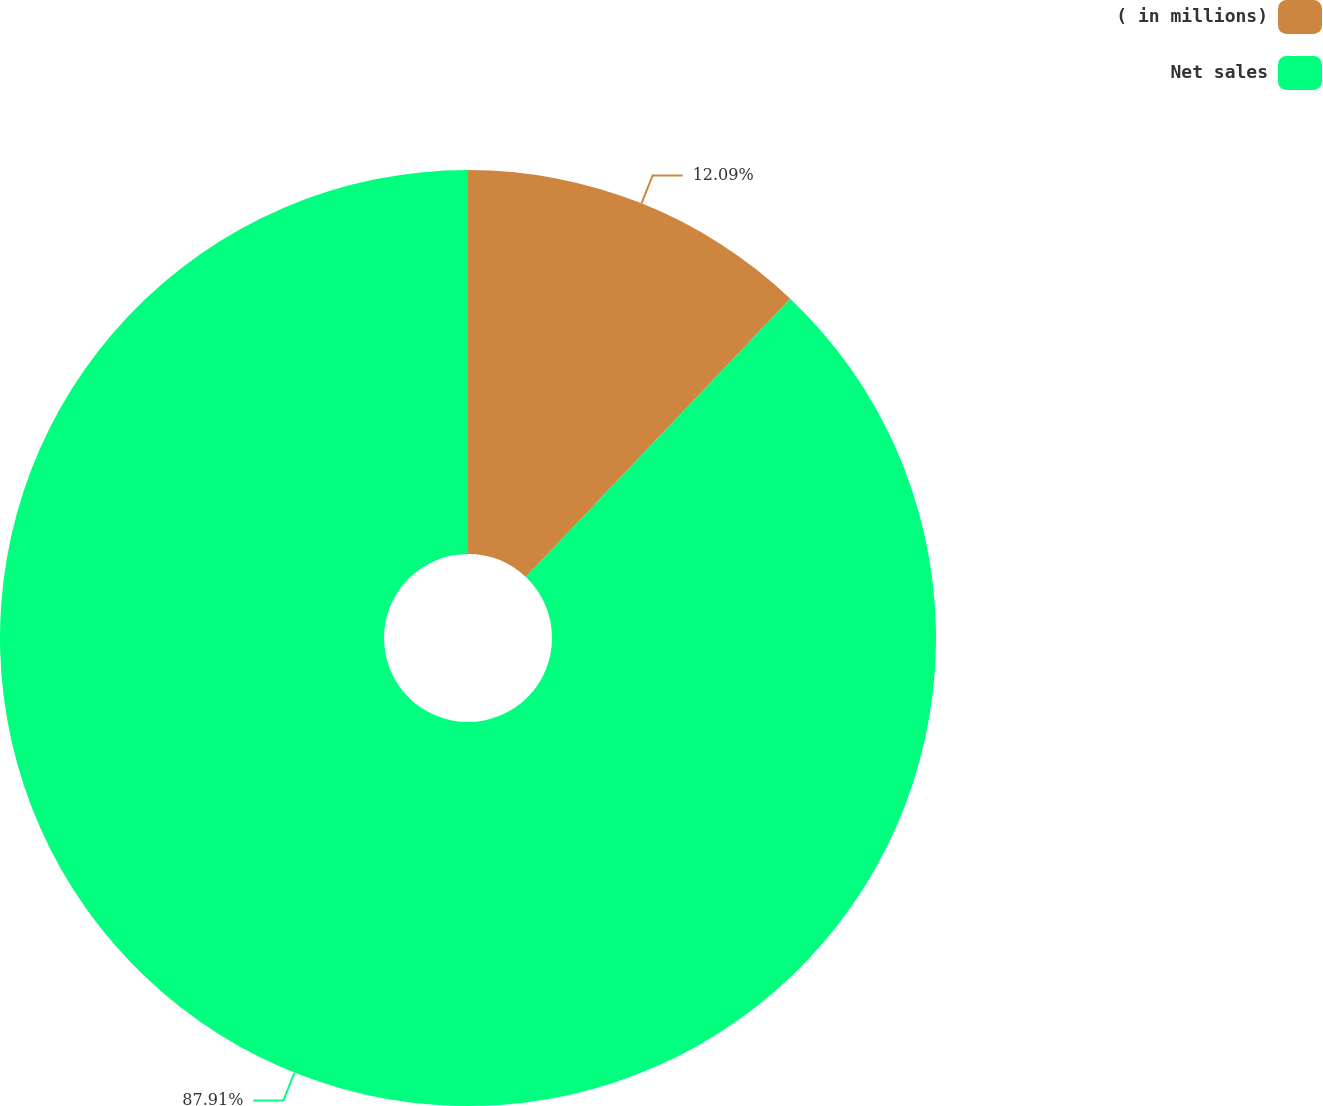Convert chart. <chart><loc_0><loc_0><loc_500><loc_500><pie_chart><fcel>( in millions)<fcel>Net sales<nl><fcel>12.09%<fcel>87.91%<nl></chart> 